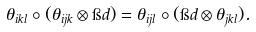<formula> <loc_0><loc_0><loc_500><loc_500>\theta _ { i k l } \circ ( \theta _ { i j k } \otimes \i d ) = \theta _ { i j l } \circ ( \i d \otimes \theta _ { j k l } ) .</formula> 